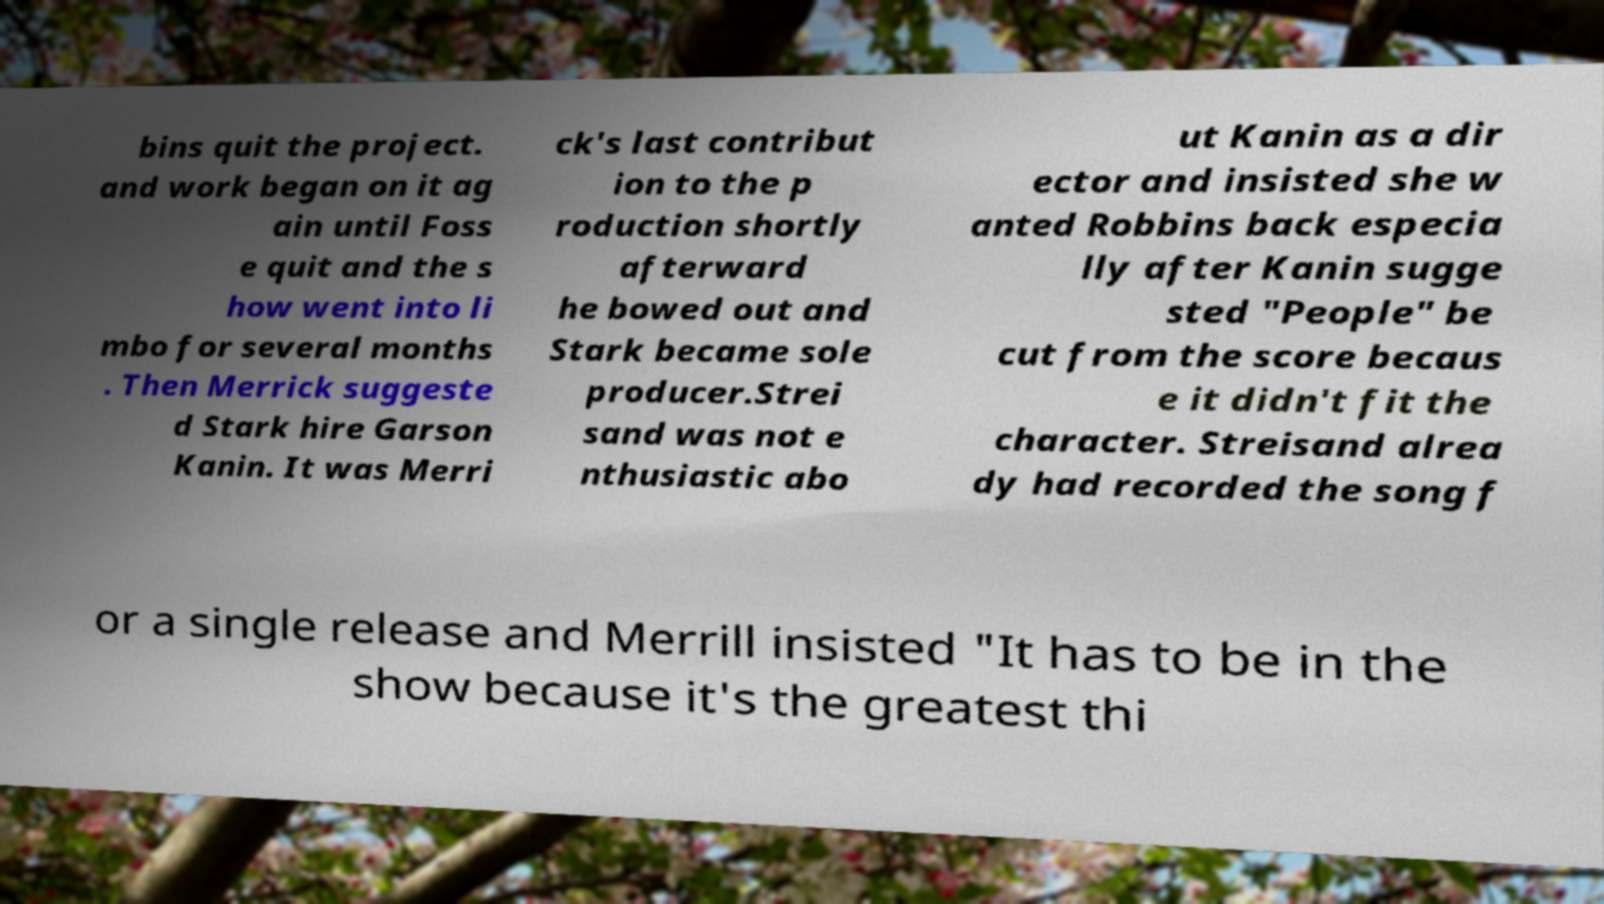There's text embedded in this image that I need extracted. Can you transcribe it verbatim? bins quit the project. and work began on it ag ain until Foss e quit and the s how went into li mbo for several months . Then Merrick suggeste d Stark hire Garson Kanin. It was Merri ck's last contribut ion to the p roduction shortly afterward he bowed out and Stark became sole producer.Strei sand was not e nthusiastic abo ut Kanin as a dir ector and insisted she w anted Robbins back especia lly after Kanin sugge sted "People" be cut from the score becaus e it didn't fit the character. Streisand alrea dy had recorded the song f or a single release and Merrill insisted "It has to be in the show because it's the greatest thi 